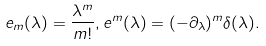<formula> <loc_0><loc_0><loc_500><loc_500>e _ { m } ( \lambda ) = \frac { \lambda ^ { m } } { m ! } , e ^ { m } ( \lambda ) = ( - \partial _ { \lambda } ) ^ { m } \delta ( \lambda ) .</formula> 